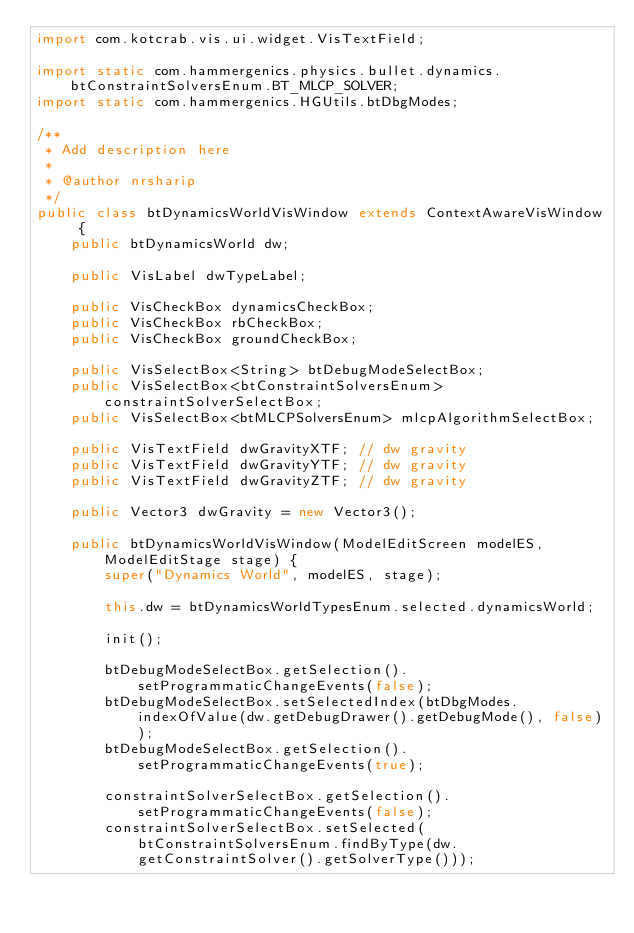Convert code to text. <code><loc_0><loc_0><loc_500><loc_500><_Java_>import com.kotcrab.vis.ui.widget.VisTextField;

import static com.hammergenics.physics.bullet.dynamics.btConstraintSolversEnum.BT_MLCP_SOLVER;
import static com.hammergenics.HGUtils.btDbgModes;

/**
 * Add description here
 *
 * @author nrsharip
 */
public class btDynamicsWorldVisWindow extends ContextAwareVisWindow {
    public btDynamicsWorld dw;

    public VisLabel dwTypeLabel;

    public VisCheckBox dynamicsCheckBox;
    public VisCheckBox rbCheckBox;
    public VisCheckBox groundCheckBox;

    public VisSelectBox<String> btDebugModeSelectBox;
    public VisSelectBox<btConstraintSolversEnum> constraintSolverSelectBox;
    public VisSelectBox<btMLCPSolversEnum> mlcpAlgorithmSelectBox;

    public VisTextField dwGravityXTF; // dw gravity
    public VisTextField dwGravityYTF; // dw gravity
    public VisTextField dwGravityZTF; // dw gravity

    public Vector3 dwGravity = new Vector3();
    
    public btDynamicsWorldVisWindow(ModelEditScreen modelES, ModelEditStage stage) {
        super("Dynamics World", modelES, stage);

        this.dw = btDynamicsWorldTypesEnum.selected.dynamicsWorld;

        init();

        btDebugModeSelectBox.getSelection().setProgrammaticChangeEvents(false);
        btDebugModeSelectBox.setSelectedIndex(btDbgModes.indexOfValue(dw.getDebugDrawer().getDebugMode(), false));
        btDebugModeSelectBox.getSelection().setProgrammaticChangeEvents(true);

        constraintSolverSelectBox.getSelection().setProgrammaticChangeEvents(false);
        constraintSolverSelectBox.setSelected(btConstraintSolversEnum.findByType(dw.getConstraintSolver().getSolverType()));</code> 